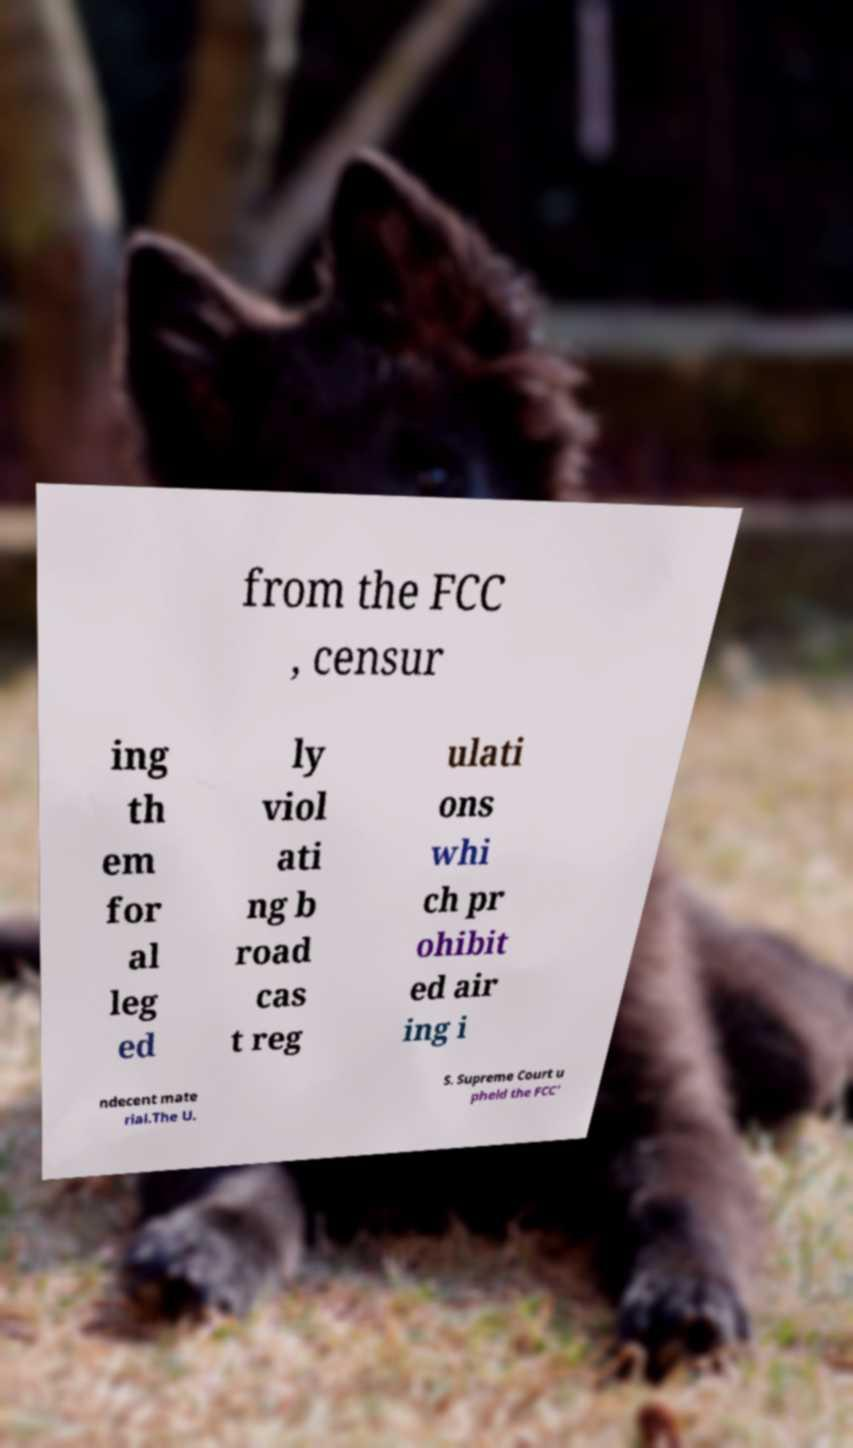Please read and relay the text visible in this image. What does it say? from the FCC , censur ing th em for al leg ed ly viol ati ng b road cas t reg ulati ons whi ch pr ohibit ed air ing i ndecent mate rial.The U. S. Supreme Court u pheld the FCC' 